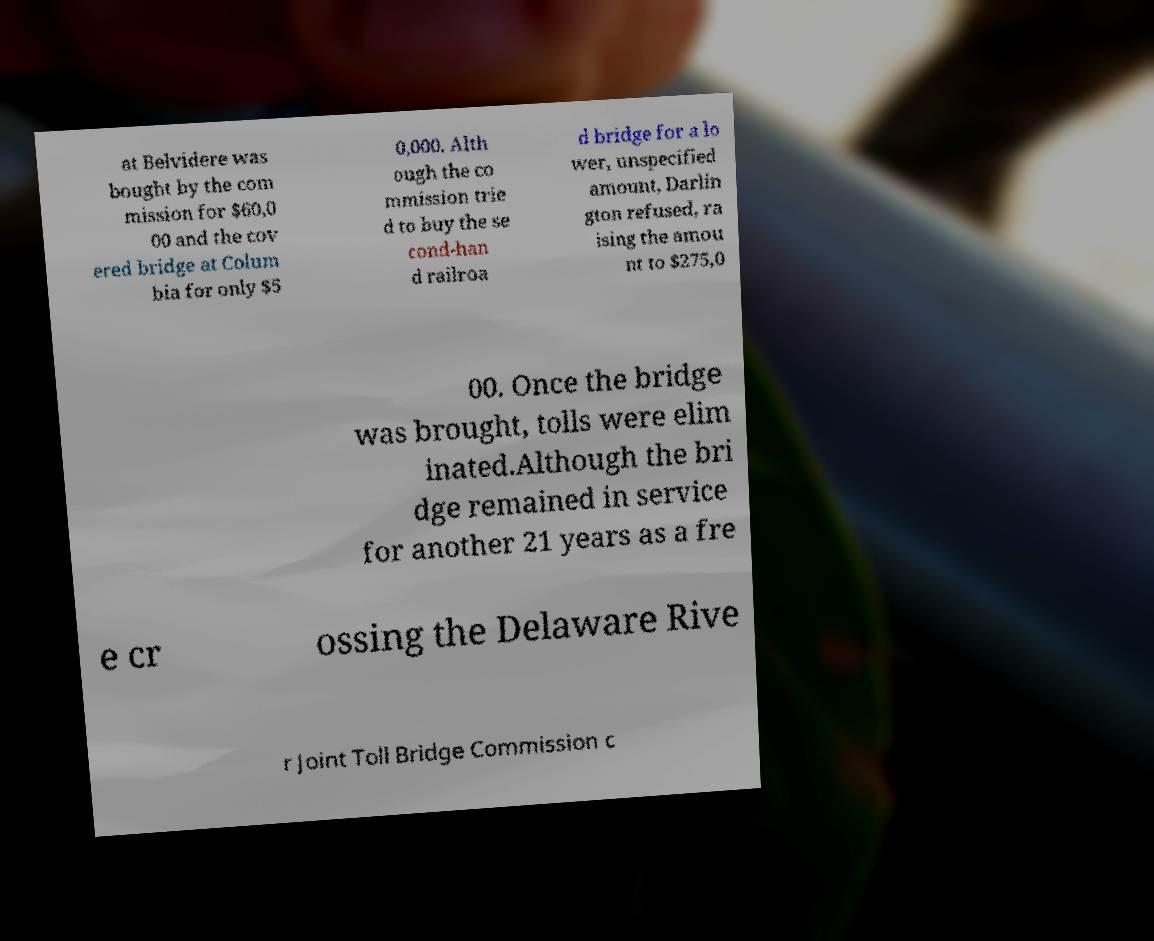Please identify and transcribe the text found in this image. at Belvidere was bought by the com mission for $60,0 00 and the cov ered bridge at Colum bia for only $5 0,000. Alth ough the co mmission trie d to buy the se cond-han d railroa d bridge for a lo wer, unspecified amount, Darlin gton refused, ra ising the amou nt to $275,0 00. Once the bridge was brought, tolls were elim inated.Although the bri dge remained in service for another 21 years as a fre e cr ossing the Delaware Rive r Joint Toll Bridge Commission c 